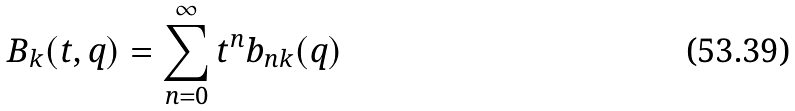<formula> <loc_0><loc_0><loc_500><loc_500>B _ { k } ( t , q ) = \sum _ { n = 0 } ^ { \infty } t ^ { n } b _ { n k } ( q )</formula> 